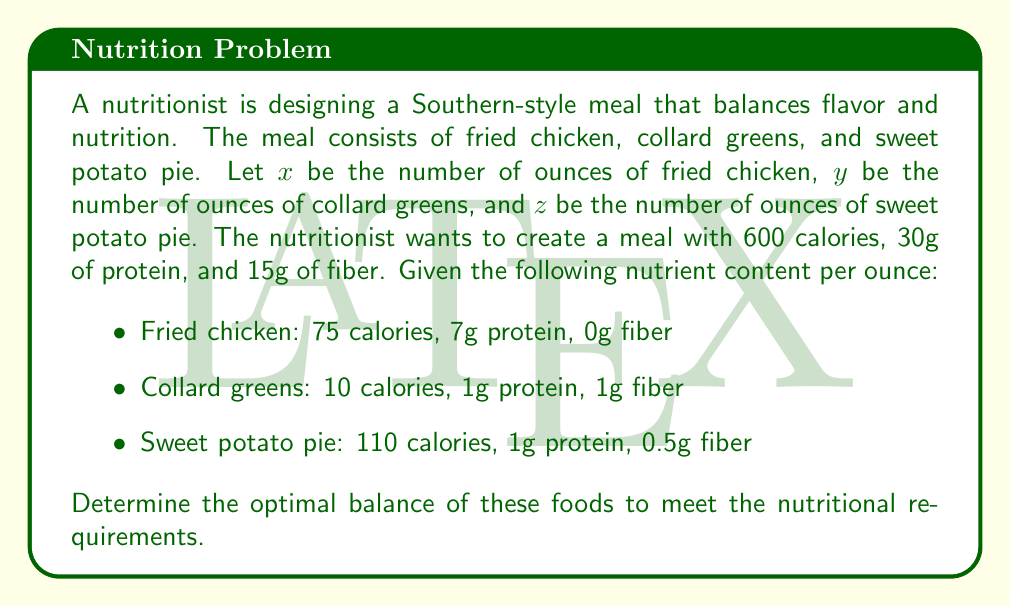Give your solution to this math problem. To solve this problem, we need to set up a system of equations based on the given information:

1. Calories equation:
   $$75x + 10y + 110z = 600$$

2. Protein equation:
   $$7x + y + z = 30$$

3. Fiber equation:
   $$y + 0.5z = 15$$

Now, let's solve this system of equations:

Step 1: From the fiber equation, express $y$ in terms of $z$:
$$y = 15 - 0.5z$$

Step 2: Substitute this into the protein equation:
$$7x + (15 - 0.5z) + z = 30$$
$$7x + 15 + 0.5z = 30$$
$$7x + 0.5z = 15$$ (Equation A)

Step 3: Substitute $y = 15 - 0.5z$ into the calories equation:
$$75x + 10(15 - 0.5z) + 110z = 600$$
$$75x + 150 - 5z + 110z = 600$$
$$75x + 105z = 450$$ (Equation B)

Step 4: Multiply Equation A by 15:
$$105x + 7.5z = 225$$ (Equation C)

Step 5: Subtract Equation C from Equation B:
$$97.5z = 225$$
$$z = \frac{225}{97.5} = \frac{20}{7} \approx 2.86$$

Step 6: Substitute $z$ back into Equation A:
$$7x + 0.5(\frac{20}{7}) = 15$$
$$7x = 15 - \frac{10}{7}$$
$$x = \frac{95}{49} \approx 1.94$$

Step 7: Calculate $y$ using the fiber equation:
$$y = 15 - 0.5(\frac{20}{7}) = \frac{95}{14} \approx 6.79$$

Therefore, the optimal balance is approximately:
- Fried chicken: 1.94 ounces
- Collard greens: 6.79 ounces
- Sweet potato pie: 2.86 ounces
Answer: $x \approx 1.94, y \approx 6.79, z \approx 2.86$ 